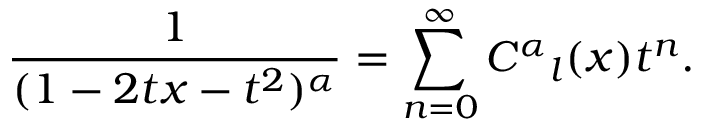<formula> <loc_0><loc_0><loc_500><loc_500>\frac { 1 } { ( 1 - 2 t x - t ^ { 2 } ) ^ { \alpha } } = \sum _ { n = 0 } ^ { \infty } C ^ { \alpha _ { l } ( x ) t ^ { n } .</formula> 